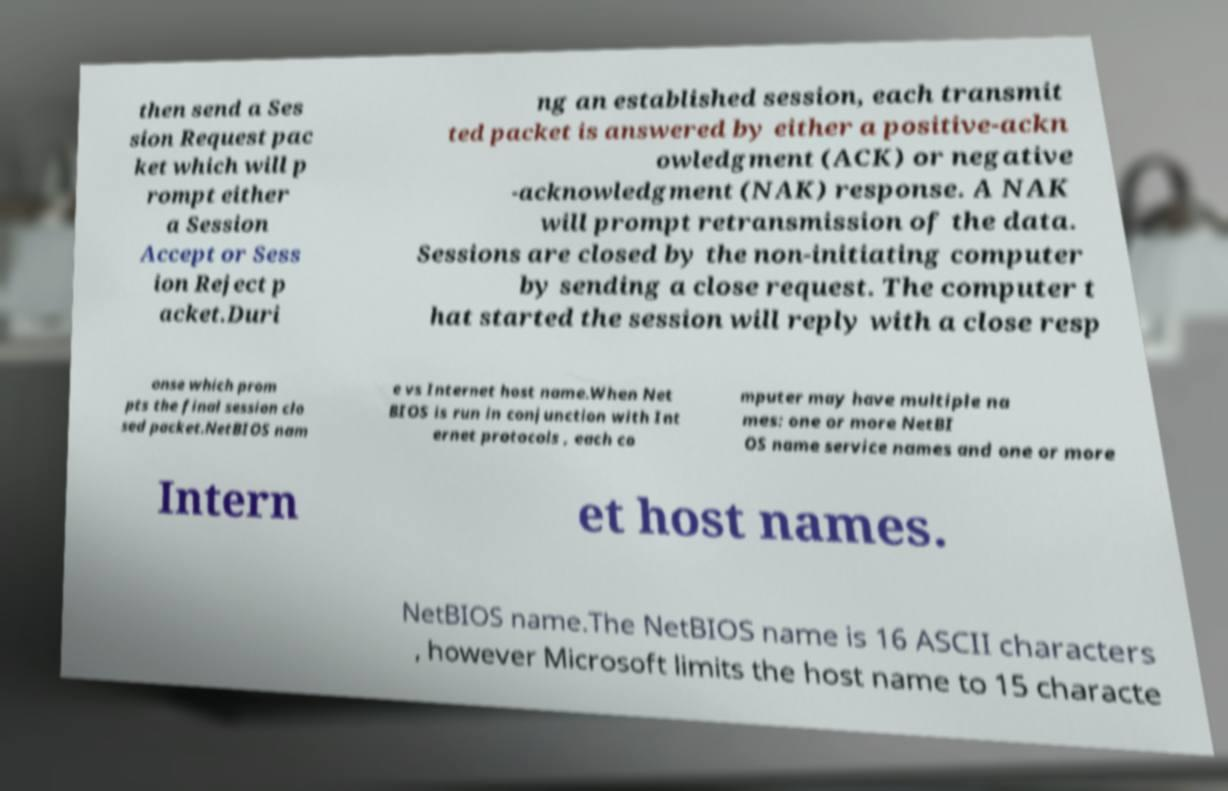For documentation purposes, I need the text within this image transcribed. Could you provide that? then send a Ses sion Request pac ket which will p rompt either a Session Accept or Sess ion Reject p acket.Duri ng an established session, each transmit ted packet is answered by either a positive-ackn owledgment (ACK) or negative -acknowledgment (NAK) response. A NAK will prompt retransmission of the data. Sessions are closed by the non-initiating computer by sending a close request. The computer t hat started the session will reply with a close resp onse which prom pts the final session clo sed packet.NetBIOS nam e vs Internet host name.When Net BIOS is run in conjunction with Int ernet protocols , each co mputer may have multiple na mes: one or more NetBI OS name service names and one or more Intern et host names. NetBIOS name.The NetBIOS name is 16 ASCII characters , however Microsoft limits the host name to 15 characte 